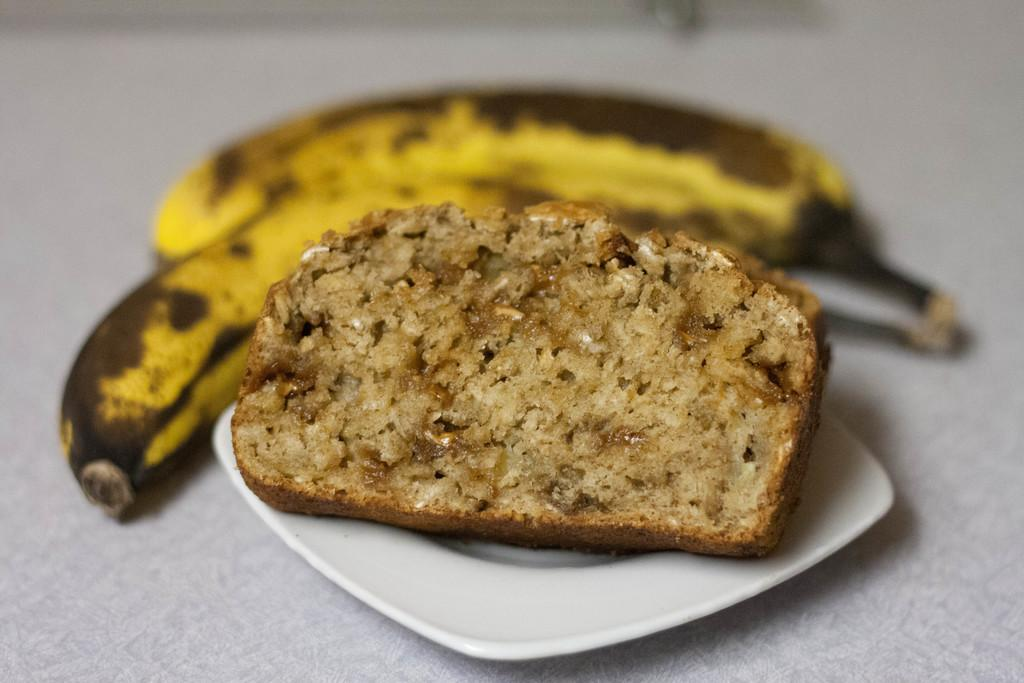What is the main food item visible on the plate in the image? Unfortunately, the specific food item cannot be determined from the given facts. What type of fruit can be seen in the image? There are bananas in the image. What color is the mother's pail in the image? There is no mention of a mother or a pail in the given facts, so this question cannot be answered. 